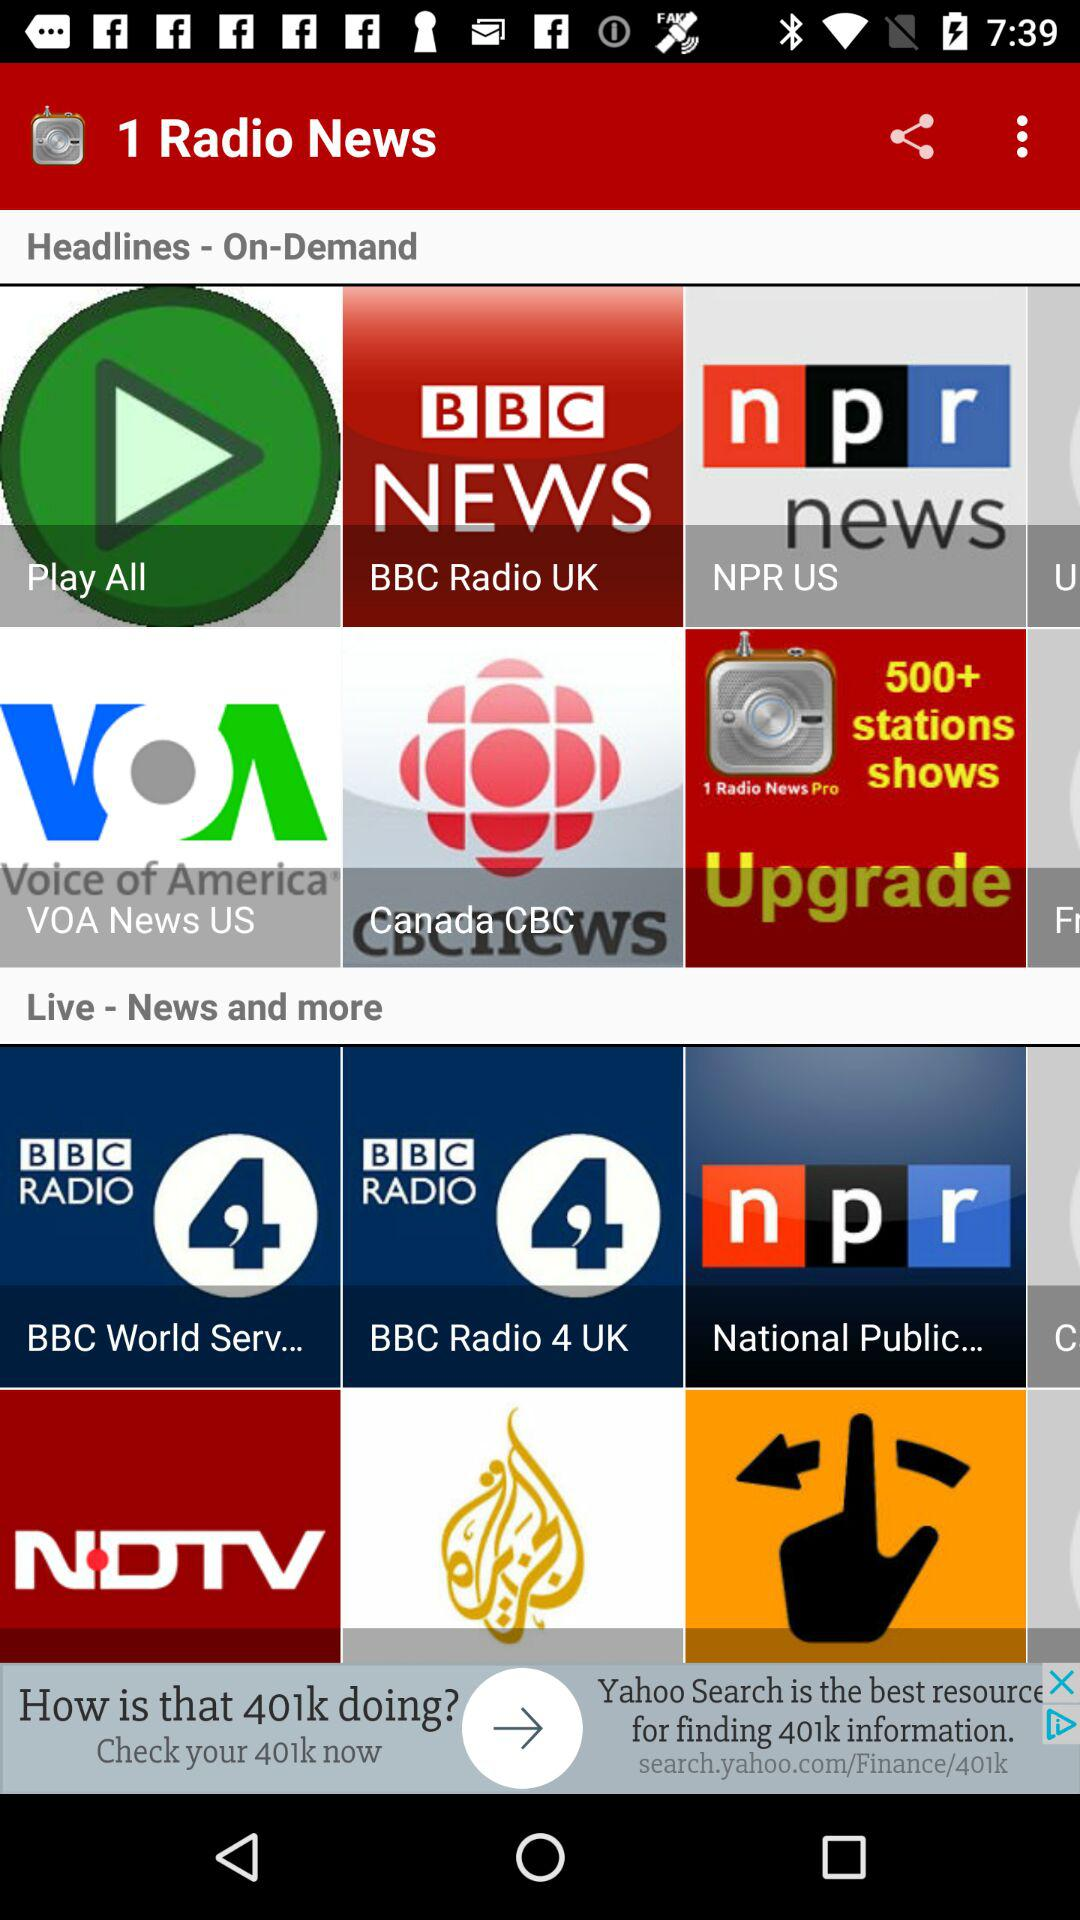What is the name of the application? The name of the application is "1 Radio News". 